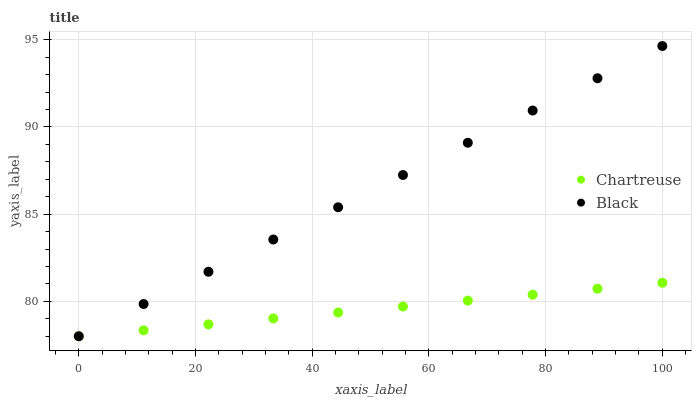Does Chartreuse have the minimum area under the curve?
Answer yes or no. Yes. Does Black have the maximum area under the curve?
Answer yes or no. Yes. Does Black have the minimum area under the curve?
Answer yes or no. No. Is Chartreuse the smoothest?
Answer yes or no. Yes. Is Black the roughest?
Answer yes or no. Yes. Is Black the smoothest?
Answer yes or no. No. Does Chartreuse have the lowest value?
Answer yes or no. Yes. Does Black have the highest value?
Answer yes or no. Yes. Does Black intersect Chartreuse?
Answer yes or no. Yes. Is Black less than Chartreuse?
Answer yes or no. No. Is Black greater than Chartreuse?
Answer yes or no. No. 